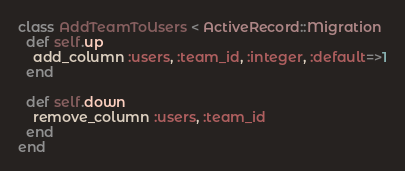Convert code to text. <code><loc_0><loc_0><loc_500><loc_500><_Ruby_>class AddTeamToUsers < ActiveRecord::Migration
  def self.up
    add_column :users, :team_id, :integer, :default=>1
  end

  def self.down
    remove_column :users, :team_id
  end
end
</code> 